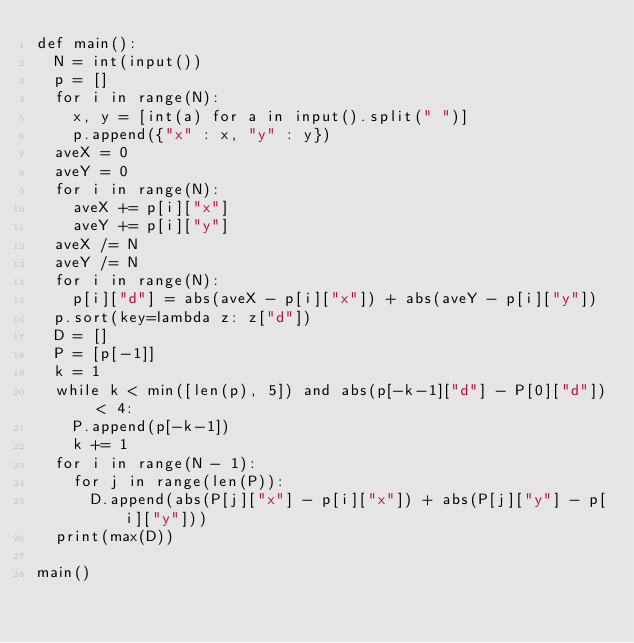Convert code to text. <code><loc_0><loc_0><loc_500><loc_500><_Python_>def main():
	N = int(input())
	p = []
	for i in range(N):
		x, y = [int(a) for a in input().split(" ")]
		p.append({"x" : x, "y" : y})
	aveX = 0
	aveY = 0
	for i in range(N):
		aveX += p[i]["x"]
		aveY += p[i]["y"]
	aveX /= N
	aveY /= N
	for i in range(N):
		p[i]["d"] = abs(aveX - p[i]["x"]) + abs(aveY - p[i]["y"])
	p.sort(key=lambda z: z["d"])
	D = []
	P = [p[-1]]
	k = 1
	while k < min([len(p), 5]) and abs(p[-k-1]["d"] - P[0]["d"]) < 4:
		P.append(p[-k-1])
		k += 1
	for i in range(N - 1):
		for j in range(len(P)):
			D.append(abs(P[j]["x"] - p[i]["x"]) + abs(P[j]["y"] - p[i]["y"]))
	print(max(D))

main()</code> 